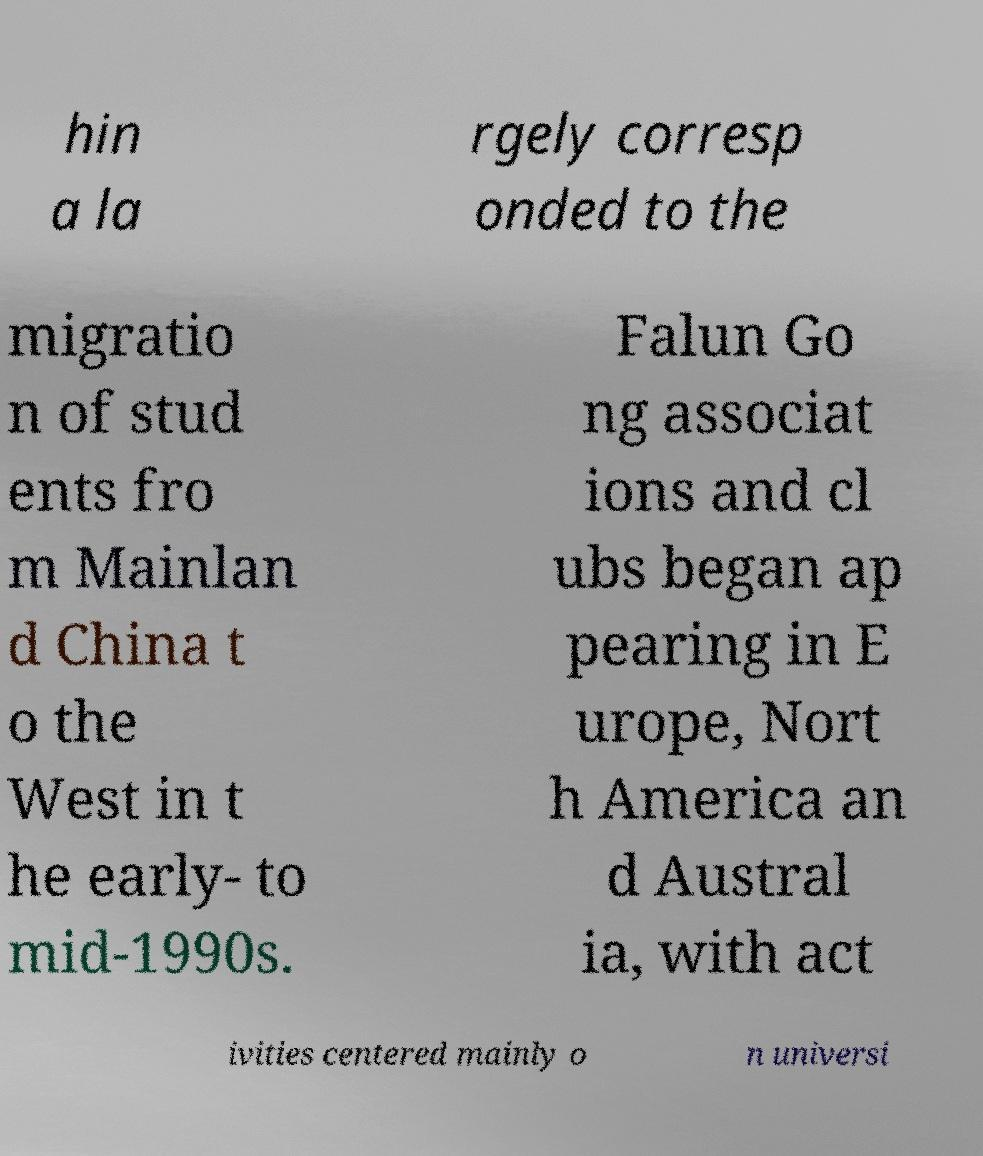Can you accurately transcribe the text from the provided image for me? hin a la rgely corresp onded to the migratio n of stud ents fro m Mainlan d China t o the West in t he early- to mid-1990s. Falun Go ng associat ions and cl ubs began ap pearing in E urope, Nort h America an d Austral ia, with act ivities centered mainly o n universi 